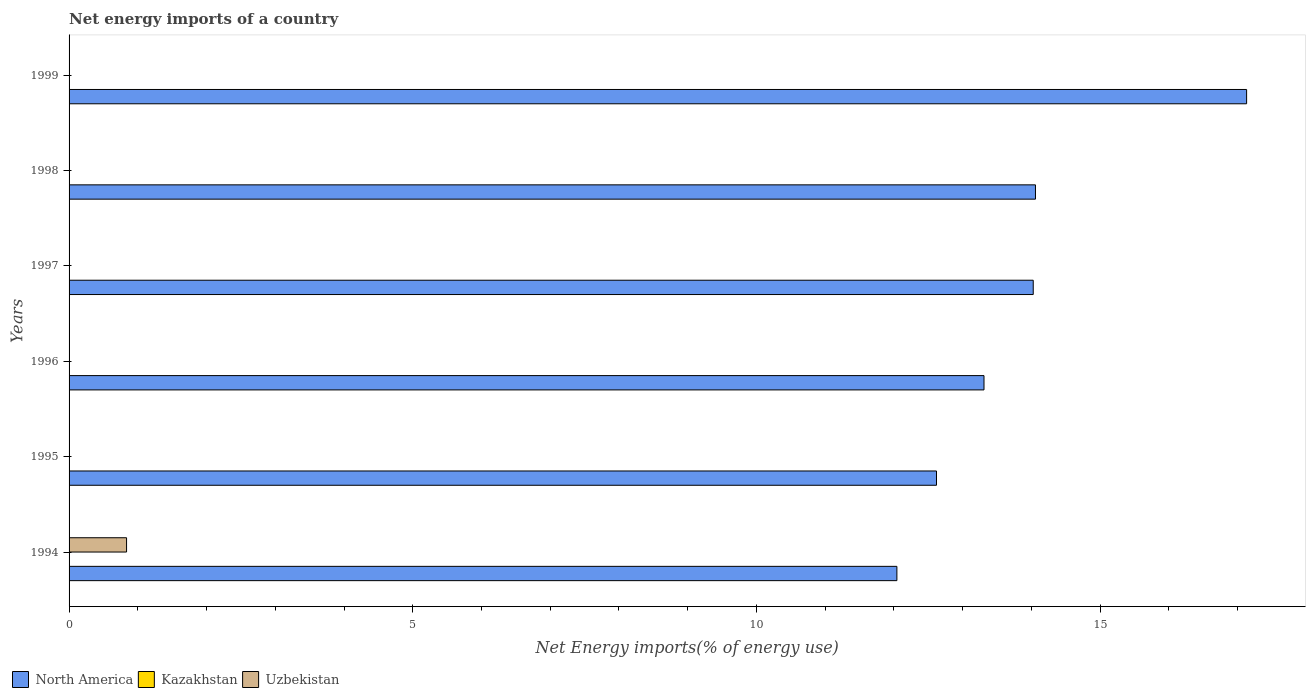How many different coloured bars are there?
Ensure brevity in your answer.  2. Are the number of bars on each tick of the Y-axis equal?
Give a very brief answer. No. How many bars are there on the 1st tick from the bottom?
Your answer should be very brief. 2. What is the label of the 1st group of bars from the top?
Provide a short and direct response. 1999. In how many cases, is the number of bars for a given year not equal to the number of legend labels?
Provide a succinct answer. 6. Across all years, what is the maximum net energy imports in Uzbekistan?
Offer a terse response. 0.84. What is the total net energy imports in Uzbekistan in the graph?
Provide a short and direct response. 0.84. What is the difference between the net energy imports in North America in 1994 and that in 1998?
Make the answer very short. -2.02. What is the difference between the net energy imports in Kazakhstan in 1994 and the net energy imports in North America in 1997?
Ensure brevity in your answer.  -14.03. What is the average net energy imports in North America per year?
Keep it short and to the point. 13.87. In the year 1994, what is the difference between the net energy imports in Uzbekistan and net energy imports in North America?
Provide a short and direct response. -11.21. In how many years, is the net energy imports in North America greater than 1 %?
Offer a very short reply. 6. What is the ratio of the net energy imports in North America in 1998 to that in 1999?
Provide a short and direct response. 0.82. Is the net energy imports in North America in 1998 less than that in 1999?
Offer a terse response. Yes. What is the difference between the highest and the second highest net energy imports in North America?
Provide a succinct answer. 3.07. What is the difference between the highest and the lowest net energy imports in Uzbekistan?
Make the answer very short. 0.84. Is it the case that in every year, the sum of the net energy imports in North America and net energy imports in Kazakhstan is greater than the net energy imports in Uzbekistan?
Offer a terse response. Yes. Are all the bars in the graph horizontal?
Offer a terse response. Yes. Does the graph contain any zero values?
Offer a terse response. Yes. Where does the legend appear in the graph?
Your answer should be very brief. Bottom left. How are the legend labels stacked?
Offer a terse response. Horizontal. What is the title of the graph?
Your response must be concise. Net energy imports of a country. Does "Saudi Arabia" appear as one of the legend labels in the graph?
Offer a terse response. No. What is the label or title of the X-axis?
Your answer should be compact. Net Energy imports(% of energy use). What is the label or title of the Y-axis?
Ensure brevity in your answer.  Years. What is the Net Energy imports(% of energy use) of North America in 1994?
Offer a terse response. 12.04. What is the Net Energy imports(% of energy use) in Uzbekistan in 1994?
Offer a terse response. 0.84. What is the Net Energy imports(% of energy use) in North America in 1995?
Give a very brief answer. 12.62. What is the Net Energy imports(% of energy use) of Kazakhstan in 1995?
Your answer should be very brief. 0. What is the Net Energy imports(% of energy use) of Uzbekistan in 1995?
Offer a terse response. 0. What is the Net Energy imports(% of energy use) in North America in 1996?
Keep it short and to the point. 13.31. What is the Net Energy imports(% of energy use) of Kazakhstan in 1996?
Your response must be concise. 0. What is the Net Energy imports(% of energy use) of North America in 1997?
Provide a short and direct response. 14.03. What is the Net Energy imports(% of energy use) of Kazakhstan in 1997?
Offer a terse response. 0. What is the Net Energy imports(% of energy use) in North America in 1998?
Your answer should be compact. 14.06. What is the Net Energy imports(% of energy use) of Kazakhstan in 1998?
Provide a succinct answer. 0. What is the Net Energy imports(% of energy use) in North America in 1999?
Give a very brief answer. 17.13. What is the Net Energy imports(% of energy use) in Kazakhstan in 1999?
Provide a succinct answer. 0. Across all years, what is the maximum Net Energy imports(% of energy use) in North America?
Your response must be concise. 17.13. Across all years, what is the maximum Net Energy imports(% of energy use) of Uzbekistan?
Your response must be concise. 0.84. Across all years, what is the minimum Net Energy imports(% of energy use) of North America?
Ensure brevity in your answer.  12.04. What is the total Net Energy imports(% of energy use) of North America in the graph?
Ensure brevity in your answer.  83.19. What is the total Net Energy imports(% of energy use) of Uzbekistan in the graph?
Keep it short and to the point. 0.84. What is the difference between the Net Energy imports(% of energy use) of North America in 1994 and that in 1995?
Make the answer very short. -0.58. What is the difference between the Net Energy imports(% of energy use) of North America in 1994 and that in 1996?
Offer a very short reply. -1.27. What is the difference between the Net Energy imports(% of energy use) in North America in 1994 and that in 1997?
Your answer should be very brief. -1.98. What is the difference between the Net Energy imports(% of energy use) in North America in 1994 and that in 1998?
Ensure brevity in your answer.  -2.02. What is the difference between the Net Energy imports(% of energy use) in North America in 1994 and that in 1999?
Offer a very short reply. -5.09. What is the difference between the Net Energy imports(% of energy use) of North America in 1995 and that in 1996?
Give a very brief answer. -0.69. What is the difference between the Net Energy imports(% of energy use) of North America in 1995 and that in 1997?
Offer a terse response. -1.41. What is the difference between the Net Energy imports(% of energy use) in North America in 1995 and that in 1998?
Ensure brevity in your answer.  -1.44. What is the difference between the Net Energy imports(% of energy use) in North America in 1995 and that in 1999?
Make the answer very short. -4.51. What is the difference between the Net Energy imports(% of energy use) of North America in 1996 and that in 1997?
Make the answer very short. -0.72. What is the difference between the Net Energy imports(% of energy use) in North America in 1996 and that in 1998?
Your answer should be compact. -0.75. What is the difference between the Net Energy imports(% of energy use) of North America in 1996 and that in 1999?
Give a very brief answer. -3.82. What is the difference between the Net Energy imports(% of energy use) in North America in 1997 and that in 1998?
Your response must be concise. -0.03. What is the difference between the Net Energy imports(% of energy use) of North America in 1997 and that in 1999?
Provide a succinct answer. -3.1. What is the difference between the Net Energy imports(% of energy use) in North America in 1998 and that in 1999?
Your answer should be compact. -3.07. What is the average Net Energy imports(% of energy use) in North America per year?
Provide a short and direct response. 13.87. What is the average Net Energy imports(% of energy use) in Uzbekistan per year?
Your answer should be compact. 0.14. In the year 1994, what is the difference between the Net Energy imports(% of energy use) in North America and Net Energy imports(% of energy use) in Uzbekistan?
Give a very brief answer. 11.21. What is the ratio of the Net Energy imports(% of energy use) of North America in 1994 to that in 1995?
Your answer should be very brief. 0.95. What is the ratio of the Net Energy imports(% of energy use) of North America in 1994 to that in 1996?
Your response must be concise. 0.9. What is the ratio of the Net Energy imports(% of energy use) in North America in 1994 to that in 1997?
Give a very brief answer. 0.86. What is the ratio of the Net Energy imports(% of energy use) of North America in 1994 to that in 1998?
Keep it short and to the point. 0.86. What is the ratio of the Net Energy imports(% of energy use) in North America in 1994 to that in 1999?
Your response must be concise. 0.7. What is the ratio of the Net Energy imports(% of energy use) of North America in 1995 to that in 1996?
Give a very brief answer. 0.95. What is the ratio of the Net Energy imports(% of energy use) of North America in 1995 to that in 1997?
Provide a succinct answer. 0.9. What is the ratio of the Net Energy imports(% of energy use) of North America in 1995 to that in 1998?
Give a very brief answer. 0.9. What is the ratio of the Net Energy imports(% of energy use) of North America in 1995 to that in 1999?
Your response must be concise. 0.74. What is the ratio of the Net Energy imports(% of energy use) of North America in 1996 to that in 1997?
Give a very brief answer. 0.95. What is the ratio of the Net Energy imports(% of energy use) of North America in 1996 to that in 1998?
Provide a short and direct response. 0.95. What is the ratio of the Net Energy imports(% of energy use) of North America in 1996 to that in 1999?
Your answer should be very brief. 0.78. What is the ratio of the Net Energy imports(% of energy use) of North America in 1997 to that in 1999?
Ensure brevity in your answer.  0.82. What is the ratio of the Net Energy imports(% of energy use) of North America in 1998 to that in 1999?
Give a very brief answer. 0.82. What is the difference between the highest and the second highest Net Energy imports(% of energy use) of North America?
Keep it short and to the point. 3.07. What is the difference between the highest and the lowest Net Energy imports(% of energy use) of North America?
Provide a short and direct response. 5.09. What is the difference between the highest and the lowest Net Energy imports(% of energy use) in Uzbekistan?
Ensure brevity in your answer.  0.84. 